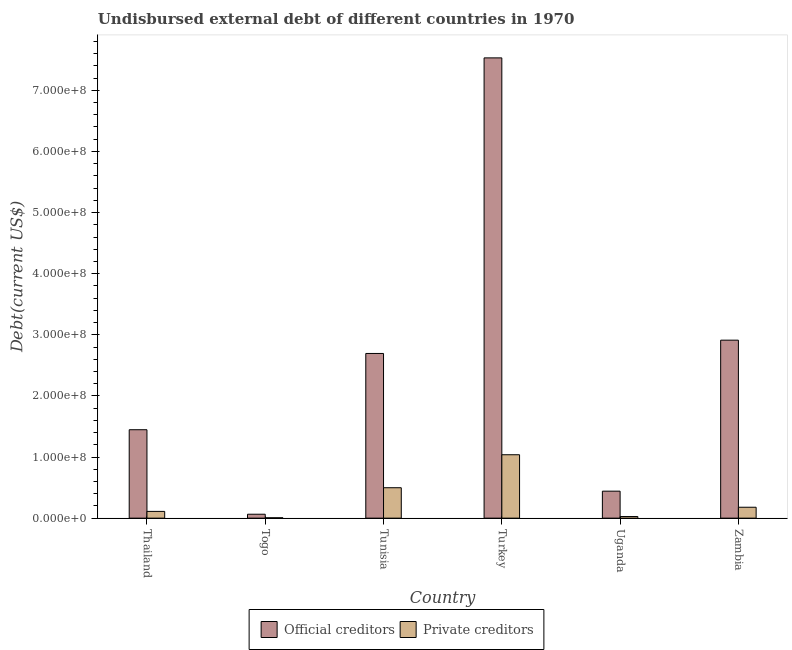How many different coloured bars are there?
Ensure brevity in your answer.  2. How many groups of bars are there?
Offer a very short reply. 6. How many bars are there on the 1st tick from the left?
Make the answer very short. 2. How many bars are there on the 1st tick from the right?
Your answer should be very brief. 2. What is the label of the 1st group of bars from the left?
Give a very brief answer. Thailand. In how many cases, is the number of bars for a given country not equal to the number of legend labels?
Your response must be concise. 0. What is the undisbursed external debt of private creditors in Tunisia?
Your answer should be very brief. 4.98e+07. Across all countries, what is the maximum undisbursed external debt of private creditors?
Provide a short and direct response. 1.04e+08. Across all countries, what is the minimum undisbursed external debt of official creditors?
Your answer should be compact. 6.43e+06. In which country was the undisbursed external debt of official creditors maximum?
Make the answer very short. Turkey. In which country was the undisbursed external debt of private creditors minimum?
Keep it short and to the point. Togo. What is the total undisbursed external debt of private creditors in the graph?
Ensure brevity in your answer.  1.86e+08. What is the difference between the undisbursed external debt of official creditors in Thailand and that in Uganda?
Your answer should be compact. 1.01e+08. What is the difference between the undisbursed external debt of private creditors in Thailand and the undisbursed external debt of official creditors in Tunisia?
Offer a terse response. -2.58e+08. What is the average undisbursed external debt of official creditors per country?
Your answer should be compact. 2.51e+08. What is the difference between the undisbursed external debt of official creditors and undisbursed external debt of private creditors in Togo?
Give a very brief answer. 5.83e+06. What is the ratio of the undisbursed external debt of official creditors in Thailand to that in Uganda?
Provide a short and direct response. 3.28. Is the undisbursed external debt of official creditors in Togo less than that in Uganda?
Your answer should be very brief. Yes. Is the difference between the undisbursed external debt of private creditors in Thailand and Uganda greater than the difference between the undisbursed external debt of official creditors in Thailand and Uganda?
Your answer should be very brief. No. What is the difference between the highest and the second highest undisbursed external debt of official creditors?
Your response must be concise. 4.62e+08. What is the difference between the highest and the lowest undisbursed external debt of private creditors?
Give a very brief answer. 1.03e+08. In how many countries, is the undisbursed external debt of official creditors greater than the average undisbursed external debt of official creditors taken over all countries?
Offer a terse response. 3. Is the sum of the undisbursed external debt of official creditors in Togo and Turkey greater than the maximum undisbursed external debt of private creditors across all countries?
Your response must be concise. Yes. What does the 2nd bar from the left in Togo represents?
Give a very brief answer. Private creditors. What does the 2nd bar from the right in Tunisia represents?
Offer a very short reply. Official creditors. How many bars are there?
Provide a short and direct response. 12. Are the values on the major ticks of Y-axis written in scientific E-notation?
Provide a short and direct response. Yes. Does the graph contain any zero values?
Provide a short and direct response. No. Where does the legend appear in the graph?
Your response must be concise. Bottom center. How many legend labels are there?
Offer a terse response. 2. How are the legend labels stacked?
Ensure brevity in your answer.  Horizontal. What is the title of the graph?
Your answer should be very brief. Undisbursed external debt of different countries in 1970. Does "Infant" appear as one of the legend labels in the graph?
Your response must be concise. No. What is the label or title of the Y-axis?
Offer a terse response. Debt(current US$). What is the Debt(current US$) in Official creditors in Thailand?
Provide a succinct answer. 1.45e+08. What is the Debt(current US$) in Private creditors in Thailand?
Ensure brevity in your answer.  1.10e+07. What is the Debt(current US$) of Official creditors in Togo?
Your answer should be very brief. 6.43e+06. What is the Debt(current US$) in Private creditors in Togo?
Make the answer very short. 6.00e+05. What is the Debt(current US$) of Official creditors in Tunisia?
Offer a very short reply. 2.69e+08. What is the Debt(current US$) of Private creditors in Tunisia?
Provide a succinct answer. 4.98e+07. What is the Debt(current US$) in Official creditors in Turkey?
Ensure brevity in your answer.  7.53e+08. What is the Debt(current US$) in Private creditors in Turkey?
Provide a short and direct response. 1.04e+08. What is the Debt(current US$) in Official creditors in Uganda?
Make the answer very short. 4.41e+07. What is the Debt(current US$) of Private creditors in Uganda?
Provide a short and direct response. 2.62e+06. What is the Debt(current US$) in Official creditors in Zambia?
Provide a short and direct response. 2.91e+08. What is the Debt(current US$) in Private creditors in Zambia?
Offer a very short reply. 1.79e+07. Across all countries, what is the maximum Debt(current US$) of Official creditors?
Make the answer very short. 7.53e+08. Across all countries, what is the maximum Debt(current US$) in Private creditors?
Offer a terse response. 1.04e+08. Across all countries, what is the minimum Debt(current US$) of Official creditors?
Your response must be concise. 6.43e+06. What is the total Debt(current US$) in Official creditors in the graph?
Make the answer very short. 1.51e+09. What is the total Debt(current US$) of Private creditors in the graph?
Offer a very short reply. 1.86e+08. What is the difference between the Debt(current US$) of Official creditors in Thailand and that in Togo?
Keep it short and to the point. 1.38e+08. What is the difference between the Debt(current US$) in Private creditors in Thailand and that in Togo?
Your answer should be compact. 1.04e+07. What is the difference between the Debt(current US$) of Official creditors in Thailand and that in Tunisia?
Your response must be concise. -1.25e+08. What is the difference between the Debt(current US$) of Private creditors in Thailand and that in Tunisia?
Provide a short and direct response. -3.87e+07. What is the difference between the Debt(current US$) of Official creditors in Thailand and that in Turkey?
Your answer should be compact. -6.08e+08. What is the difference between the Debt(current US$) in Private creditors in Thailand and that in Turkey?
Ensure brevity in your answer.  -9.27e+07. What is the difference between the Debt(current US$) of Official creditors in Thailand and that in Uganda?
Ensure brevity in your answer.  1.01e+08. What is the difference between the Debt(current US$) of Private creditors in Thailand and that in Uganda?
Your response must be concise. 8.43e+06. What is the difference between the Debt(current US$) of Official creditors in Thailand and that in Zambia?
Your answer should be very brief. -1.47e+08. What is the difference between the Debt(current US$) in Private creditors in Thailand and that in Zambia?
Make the answer very short. -6.80e+06. What is the difference between the Debt(current US$) in Official creditors in Togo and that in Tunisia?
Give a very brief answer. -2.63e+08. What is the difference between the Debt(current US$) of Private creditors in Togo and that in Tunisia?
Provide a short and direct response. -4.92e+07. What is the difference between the Debt(current US$) in Official creditors in Togo and that in Turkey?
Provide a short and direct response. -7.47e+08. What is the difference between the Debt(current US$) in Private creditors in Togo and that in Turkey?
Offer a terse response. -1.03e+08. What is the difference between the Debt(current US$) in Official creditors in Togo and that in Uganda?
Make the answer very short. -3.77e+07. What is the difference between the Debt(current US$) of Private creditors in Togo and that in Uganda?
Offer a terse response. -2.02e+06. What is the difference between the Debt(current US$) in Official creditors in Togo and that in Zambia?
Your response must be concise. -2.85e+08. What is the difference between the Debt(current US$) of Private creditors in Togo and that in Zambia?
Keep it short and to the point. -1.73e+07. What is the difference between the Debt(current US$) of Official creditors in Tunisia and that in Turkey?
Your answer should be compact. -4.84e+08. What is the difference between the Debt(current US$) in Private creditors in Tunisia and that in Turkey?
Ensure brevity in your answer.  -5.40e+07. What is the difference between the Debt(current US$) of Official creditors in Tunisia and that in Uganda?
Provide a short and direct response. 2.25e+08. What is the difference between the Debt(current US$) of Private creditors in Tunisia and that in Uganda?
Provide a short and direct response. 4.72e+07. What is the difference between the Debt(current US$) in Official creditors in Tunisia and that in Zambia?
Your answer should be compact. -2.18e+07. What is the difference between the Debt(current US$) in Private creditors in Tunisia and that in Zambia?
Provide a succinct answer. 3.19e+07. What is the difference between the Debt(current US$) in Official creditors in Turkey and that in Uganda?
Your response must be concise. 7.09e+08. What is the difference between the Debt(current US$) in Private creditors in Turkey and that in Uganda?
Ensure brevity in your answer.  1.01e+08. What is the difference between the Debt(current US$) in Official creditors in Turkey and that in Zambia?
Your answer should be compact. 4.62e+08. What is the difference between the Debt(current US$) in Private creditors in Turkey and that in Zambia?
Offer a terse response. 8.59e+07. What is the difference between the Debt(current US$) in Official creditors in Uganda and that in Zambia?
Your answer should be very brief. -2.47e+08. What is the difference between the Debt(current US$) of Private creditors in Uganda and that in Zambia?
Keep it short and to the point. -1.52e+07. What is the difference between the Debt(current US$) in Official creditors in Thailand and the Debt(current US$) in Private creditors in Togo?
Your response must be concise. 1.44e+08. What is the difference between the Debt(current US$) in Official creditors in Thailand and the Debt(current US$) in Private creditors in Tunisia?
Make the answer very short. 9.49e+07. What is the difference between the Debt(current US$) in Official creditors in Thailand and the Debt(current US$) in Private creditors in Turkey?
Provide a succinct answer. 4.09e+07. What is the difference between the Debt(current US$) of Official creditors in Thailand and the Debt(current US$) of Private creditors in Uganda?
Ensure brevity in your answer.  1.42e+08. What is the difference between the Debt(current US$) of Official creditors in Thailand and the Debt(current US$) of Private creditors in Zambia?
Your response must be concise. 1.27e+08. What is the difference between the Debt(current US$) of Official creditors in Togo and the Debt(current US$) of Private creditors in Tunisia?
Make the answer very short. -4.34e+07. What is the difference between the Debt(current US$) in Official creditors in Togo and the Debt(current US$) in Private creditors in Turkey?
Offer a terse response. -9.73e+07. What is the difference between the Debt(current US$) in Official creditors in Togo and the Debt(current US$) in Private creditors in Uganda?
Provide a succinct answer. 3.81e+06. What is the difference between the Debt(current US$) in Official creditors in Togo and the Debt(current US$) in Private creditors in Zambia?
Offer a very short reply. -1.14e+07. What is the difference between the Debt(current US$) of Official creditors in Tunisia and the Debt(current US$) of Private creditors in Turkey?
Provide a succinct answer. 1.66e+08. What is the difference between the Debt(current US$) in Official creditors in Tunisia and the Debt(current US$) in Private creditors in Uganda?
Provide a succinct answer. 2.67e+08. What is the difference between the Debt(current US$) of Official creditors in Tunisia and the Debt(current US$) of Private creditors in Zambia?
Make the answer very short. 2.52e+08. What is the difference between the Debt(current US$) in Official creditors in Turkey and the Debt(current US$) in Private creditors in Uganda?
Make the answer very short. 7.50e+08. What is the difference between the Debt(current US$) in Official creditors in Turkey and the Debt(current US$) in Private creditors in Zambia?
Ensure brevity in your answer.  7.35e+08. What is the difference between the Debt(current US$) in Official creditors in Uganda and the Debt(current US$) in Private creditors in Zambia?
Offer a very short reply. 2.63e+07. What is the average Debt(current US$) in Official creditors per country?
Offer a very short reply. 2.51e+08. What is the average Debt(current US$) of Private creditors per country?
Give a very brief answer. 3.09e+07. What is the difference between the Debt(current US$) in Official creditors and Debt(current US$) in Private creditors in Thailand?
Provide a short and direct response. 1.34e+08. What is the difference between the Debt(current US$) in Official creditors and Debt(current US$) in Private creditors in Togo?
Offer a very short reply. 5.83e+06. What is the difference between the Debt(current US$) in Official creditors and Debt(current US$) in Private creditors in Tunisia?
Make the answer very short. 2.20e+08. What is the difference between the Debt(current US$) of Official creditors and Debt(current US$) of Private creditors in Turkey?
Offer a very short reply. 6.49e+08. What is the difference between the Debt(current US$) of Official creditors and Debt(current US$) of Private creditors in Uganda?
Your answer should be compact. 4.15e+07. What is the difference between the Debt(current US$) in Official creditors and Debt(current US$) in Private creditors in Zambia?
Your answer should be very brief. 2.73e+08. What is the ratio of the Debt(current US$) of Official creditors in Thailand to that in Togo?
Your answer should be very brief. 22.51. What is the ratio of the Debt(current US$) of Private creditors in Thailand to that in Togo?
Provide a succinct answer. 18.42. What is the ratio of the Debt(current US$) in Official creditors in Thailand to that in Tunisia?
Give a very brief answer. 0.54. What is the ratio of the Debt(current US$) in Private creditors in Thailand to that in Tunisia?
Keep it short and to the point. 0.22. What is the ratio of the Debt(current US$) of Official creditors in Thailand to that in Turkey?
Offer a terse response. 0.19. What is the ratio of the Debt(current US$) of Private creditors in Thailand to that in Turkey?
Offer a terse response. 0.11. What is the ratio of the Debt(current US$) in Official creditors in Thailand to that in Uganda?
Give a very brief answer. 3.28. What is the ratio of the Debt(current US$) of Private creditors in Thailand to that in Uganda?
Provide a short and direct response. 4.22. What is the ratio of the Debt(current US$) in Official creditors in Thailand to that in Zambia?
Provide a short and direct response. 0.5. What is the ratio of the Debt(current US$) of Private creditors in Thailand to that in Zambia?
Your answer should be very brief. 0.62. What is the ratio of the Debt(current US$) of Official creditors in Togo to that in Tunisia?
Your answer should be very brief. 0.02. What is the ratio of the Debt(current US$) of Private creditors in Togo to that in Tunisia?
Provide a succinct answer. 0.01. What is the ratio of the Debt(current US$) of Official creditors in Togo to that in Turkey?
Keep it short and to the point. 0.01. What is the ratio of the Debt(current US$) in Private creditors in Togo to that in Turkey?
Provide a short and direct response. 0.01. What is the ratio of the Debt(current US$) in Official creditors in Togo to that in Uganda?
Ensure brevity in your answer.  0.15. What is the ratio of the Debt(current US$) of Private creditors in Togo to that in Uganda?
Keep it short and to the point. 0.23. What is the ratio of the Debt(current US$) of Official creditors in Togo to that in Zambia?
Your answer should be compact. 0.02. What is the ratio of the Debt(current US$) in Private creditors in Togo to that in Zambia?
Make the answer very short. 0.03. What is the ratio of the Debt(current US$) of Official creditors in Tunisia to that in Turkey?
Provide a short and direct response. 0.36. What is the ratio of the Debt(current US$) in Private creditors in Tunisia to that in Turkey?
Provide a short and direct response. 0.48. What is the ratio of the Debt(current US$) of Official creditors in Tunisia to that in Uganda?
Your answer should be very brief. 6.1. What is the ratio of the Debt(current US$) of Private creditors in Tunisia to that in Uganda?
Your answer should be very brief. 18.99. What is the ratio of the Debt(current US$) of Official creditors in Tunisia to that in Zambia?
Provide a short and direct response. 0.93. What is the ratio of the Debt(current US$) in Private creditors in Tunisia to that in Zambia?
Provide a succinct answer. 2.79. What is the ratio of the Debt(current US$) of Official creditors in Turkey to that in Uganda?
Provide a succinct answer. 17.06. What is the ratio of the Debt(current US$) in Private creditors in Turkey to that in Uganda?
Ensure brevity in your answer.  39.58. What is the ratio of the Debt(current US$) in Official creditors in Turkey to that in Zambia?
Your response must be concise. 2.59. What is the ratio of the Debt(current US$) in Private creditors in Turkey to that in Zambia?
Ensure brevity in your answer.  5.81. What is the ratio of the Debt(current US$) of Official creditors in Uganda to that in Zambia?
Ensure brevity in your answer.  0.15. What is the ratio of the Debt(current US$) in Private creditors in Uganda to that in Zambia?
Your response must be concise. 0.15. What is the difference between the highest and the second highest Debt(current US$) of Official creditors?
Keep it short and to the point. 4.62e+08. What is the difference between the highest and the second highest Debt(current US$) in Private creditors?
Your answer should be compact. 5.40e+07. What is the difference between the highest and the lowest Debt(current US$) of Official creditors?
Provide a short and direct response. 7.47e+08. What is the difference between the highest and the lowest Debt(current US$) of Private creditors?
Keep it short and to the point. 1.03e+08. 